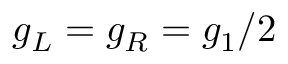Convert formula to latex. <formula><loc_0><loc_0><loc_500><loc_500>g _ { L } = g _ { R } = g _ { 1 } / 2</formula> 